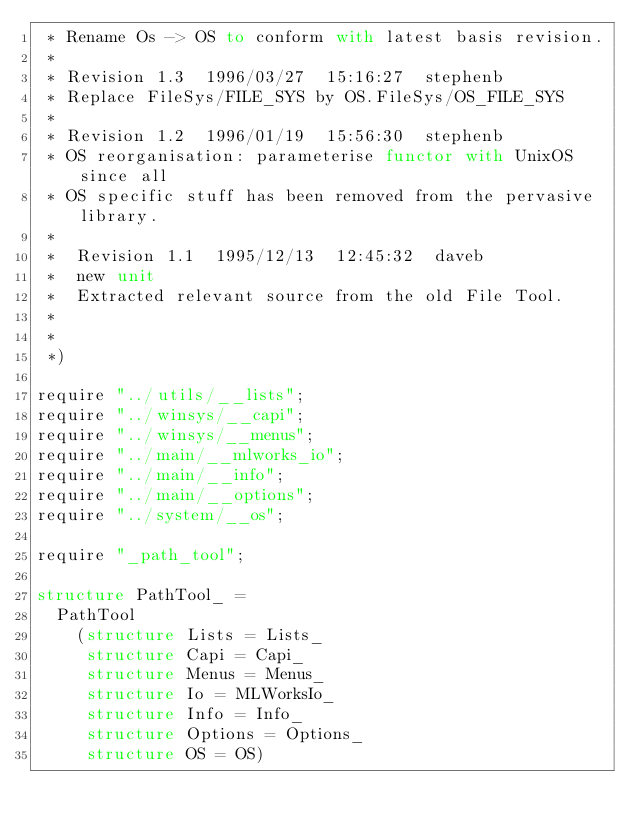<code> <loc_0><loc_0><loc_500><loc_500><_SML_> * Rename Os -> OS to conform with latest basis revision.
 *
 * Revision 1.3  1996/03/27  15:16:27  stephenb
 * Replace FileSys/FILE_SYS by OS.FileSys/OS_FILE_SYS
 *
 * Revision 1.2  1996/01/19  15:56:30  stephenb
 * OS reorganisation: parameterise functor with UnixOS since all
 * OS specific stuff has been removed from the pervasive library.
 *
 *  Revision 1.1  1995/12/13  12:45:32  daveb
 *  new unit
 *  Extracted relevant source from the old File Tool.
 *
 *
 *)

require "../utils/__lists";
require "../winsys/__capi";
require "../winsys/__menus";
require "../main/__mlworks_io";
require "../main/__info";
require "../main/__options";
require "../system/__os";

require "_path_tool";

structure PathTool_ =
  PathTool
    (structure Lists = Lists_
     structure Capi = Capi_
     structure Menus = Menus_
     structure Io = MLWorksIo_
     structure Info = Info_
     structure Options = Options_
     structure OS = OS)
</code> 